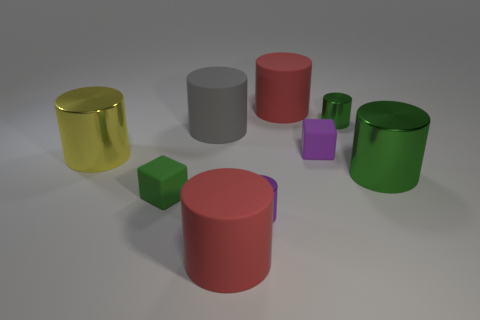How big is the red rubber cylinder that is in front of the small cylinder behind the large gray rubber cylinder? The red rubber cylinder appears to be of medium size when compared to the other objects in the image. It is located directly in front of a smaller green cylinder and behind the larger, central gray cylinder. Precise dimensions cannot be determined from the image alone, but it is visibly taller and has a larger diameter than the small purple cube and the small green cylinder nearby. 